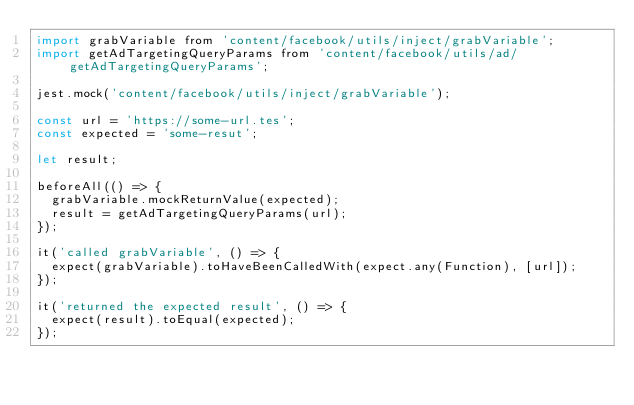Convert code to text. <code><loc_0><loc_0><loc_500><loc_500><_JavaScript_>import grabVariable from 'content/facebook/utils/inject/grabVariable';
import getAdTargetingQueryParams from 'content/facebook/utils/ad/getAdTargetingQueryParams';

jest.mock('content/facebook/utils/inject/grabVariable');

const url = 'https://some-url.tes';
const expected = 'some-resut';

let result;

beforeAll(() => {
  grabVariable.mockReturnValue(expected);
  result = getAdTargetingQueryParams(url);
});

it('called grabVariable', () => {
  expect(grabVariable).toHaveBeenCalledWith(expect.any(Function), [url]);
});

it('returned the expected result', () => {
  expect(result).toEqual(expected);
});
</code> 